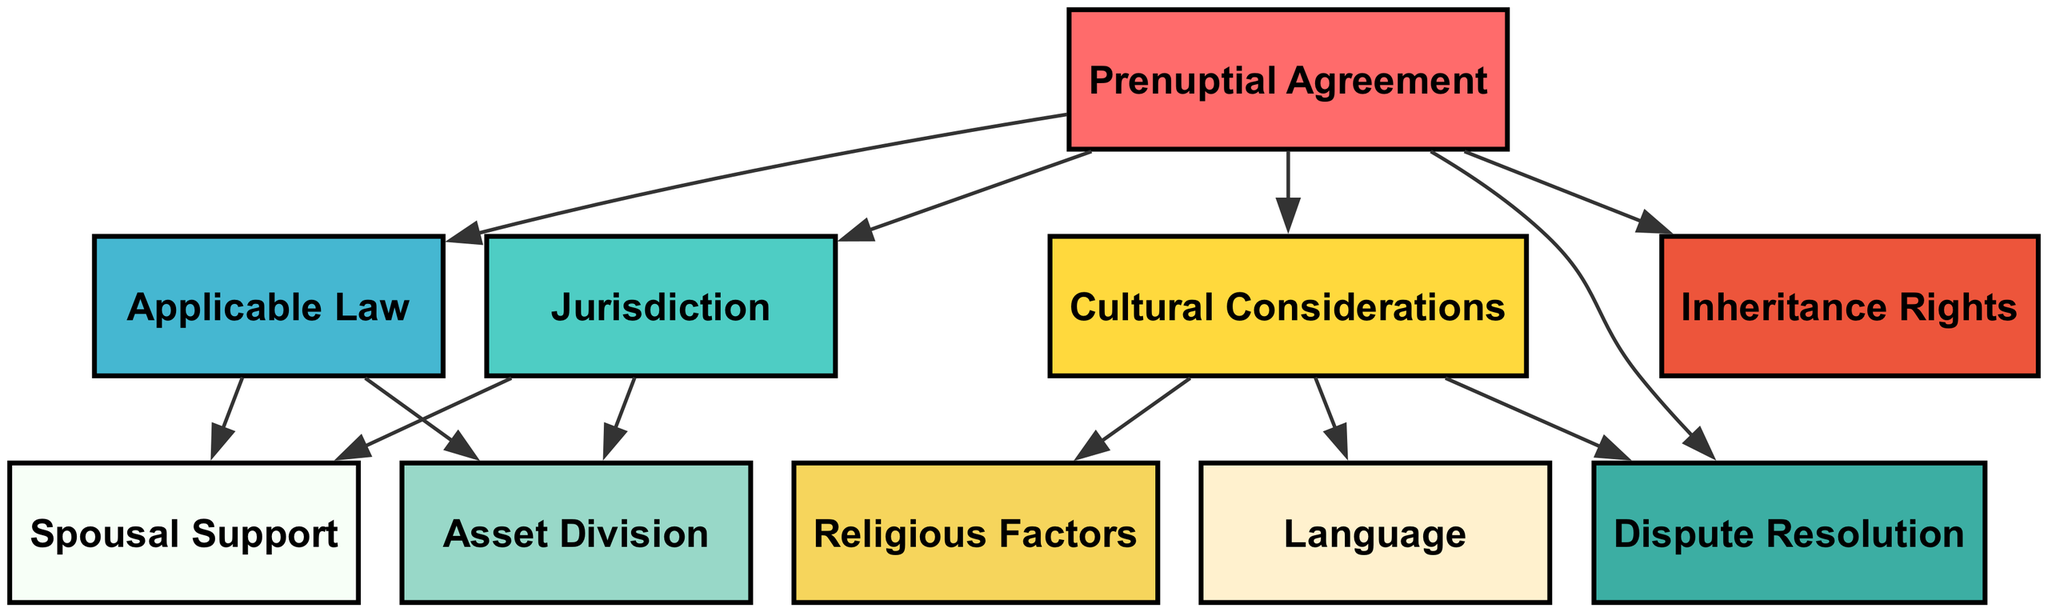What is the root node of the diagram? The root node is 'Prenuptial Agreement', which serves as the primary focus of the diagram and from which all other nodes branch out.
Answer: Prenuptial Agreement How many nodes are present in the diagram? By counting all unique nodes listed in the diagram, there are a total of 10 nodes: Prenuptial Agreement, Jurisdiction, Applicable Law, Asset Division, Spousal Support, Cultural Considerations, Language, Religious Factors, Inheritance Rights, and Dispute Resolution.
Answer: 10 Which two nodes have a direct connection from 'Jurisdiction'? There are two nodes that connect from 'Jurisdiction', which are 'Asset Division' and 'Spousal Support', showing the direct legal implications arising from the jurisdiction where the prenuptial agreement is enforced.
Answer: Asset Division, Spousal Support What is the relationship between 'Cultural Considerations' and 'Dispute Resolution'? 'Cultural Considerations' contributes to 'Dispute Resolution', meaning that cultural aspects may influence how disputes are resolved in cross-cultural prenuptial agreements.
Answer: Cultural Considerations influences Dispute Resolution How many edges are there in total? The total number of edges connecting nodes can be counted, yielding 12 edges based on the provided relationships in the diagram.
Answer: 12 Which node is directly influenced by both 'Jurisdiction' and 'Applicable Law'? The nodes 'Asset Division' and 'Spousal Support' are influenced by both 'Jurisdiction' and 'Applicable Law', indicating they are shaped by legal frameworks of both concepts.
Answer: Asset Division, Spousal Support What are the two specific areas influenced by 'Cultural Considerations'? The two areas influenced by 'Cultural Considerations' are 'Language' and 'Religious Factors', which are significant aspects of cross-cultural relationships to consider in a prenuptial agreement.
Answer: Language, Religious Factors Which node is not connected to 'Cultural Considerations'? The nodes 'Asset Division' and 'Spousal Support' are not connected to 'Cultural Considerations', indicating they are strictly legal considerations and not influenced by cultural elements.
Answer: Asset Division, Spousal Support What is the primary concern that links both 'Jurisdiction' and 'Applicable Law'? The primary concern that links both 'Jurisdiction' and 'Applicable Law' is their influence on 'Asset Division' and 'Spousal Support', signifying their importance in the legal framework of prenuptial agreements.
Answer: Asset Division, Spousal Support 